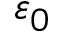Convert formula to latex. <formula><loc_0><loc_0><loc_500><loc_500>\varepsilon _ { 0 }</formula> 